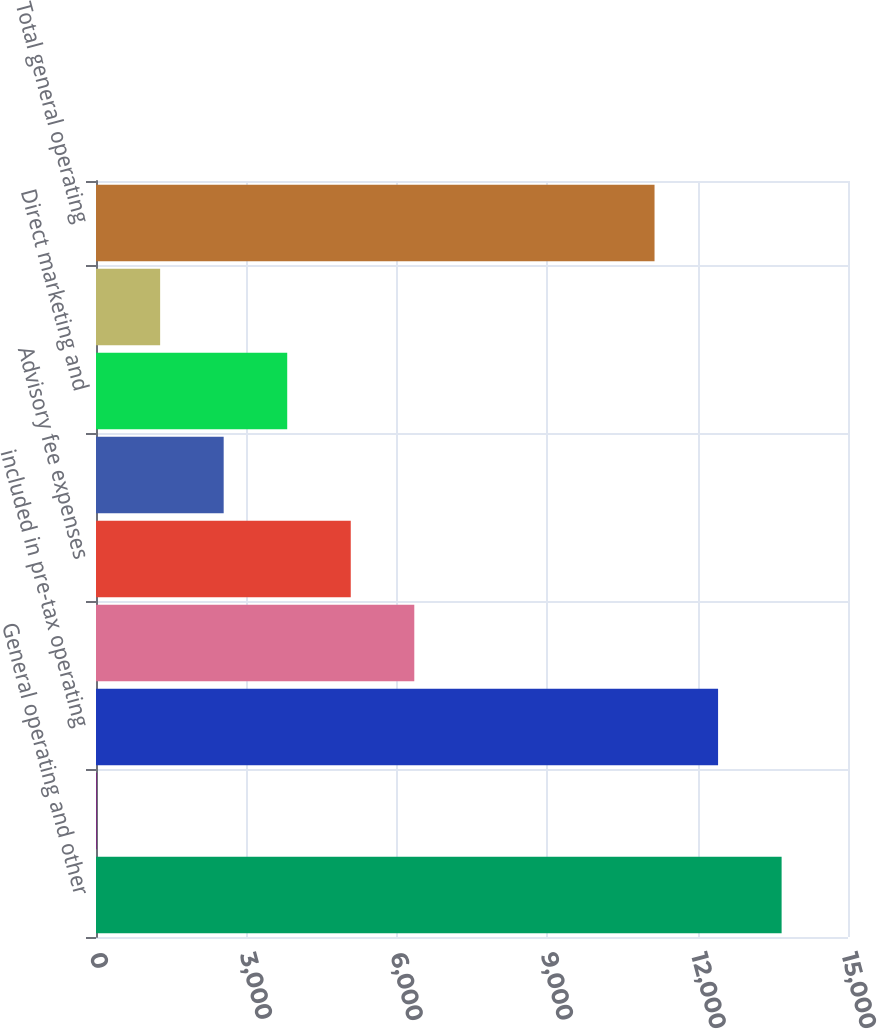Convert chart. <chart><loc_0><loc_0><loc_500><loc_500><bar_chart><fcel>General operating and other<fcel>Non-operating litigation<fcel>included in pre-tax operating<fcel>Loss adjustment expenses<fcel>Advisory fee expenses<fcel>Non-deferrable insurance<fcel>Direct marketing and<fcel>Investment expenses reported<fcel>Total general operating<nl><fcel>13675.8<fcel>12<fcel>12408.4<fcel>6349<fcel>5081.6<fcel>2546.8<fcel>3814.2<fcel>1279.4<fcel>11141<nl></chart> 